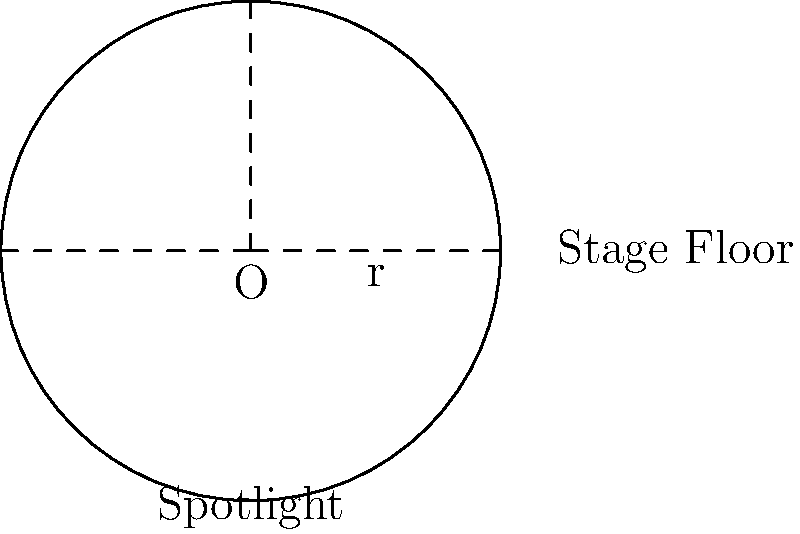As you prepare for your next Broadway performance, you notice a circular spotlight projecting onto the stage floor. If the radius of the circular light projection is 15 feet, what is the area of the illuminated region on the stage? Round your answer to the nearest square foot. Let's approach this step-by-step:

1) The formula for the area of a circle is $A = \pi r^2$, where $r$ is the radius.

2) We're given that the radius of the circular light projection is 15 feet.

3) Let's substitute this into our formula:

   $A = \pi (15)^2$

4) Simplify the exponent:
   
   $A = \pi (225)$

5) Now, let's use $\pi \approx 3.14159$ for our calculation:

   $A \approx 3.14159 \times 225$

6) Multiply:

   $A \approx 706.85775$ square feet

7) Rounding to the nearest square foot:

   $A \approx 707$ square feet

Thus, the area of the illuminated region on the stage is approximately 707 square feet.
Answer: 707 sq ft 